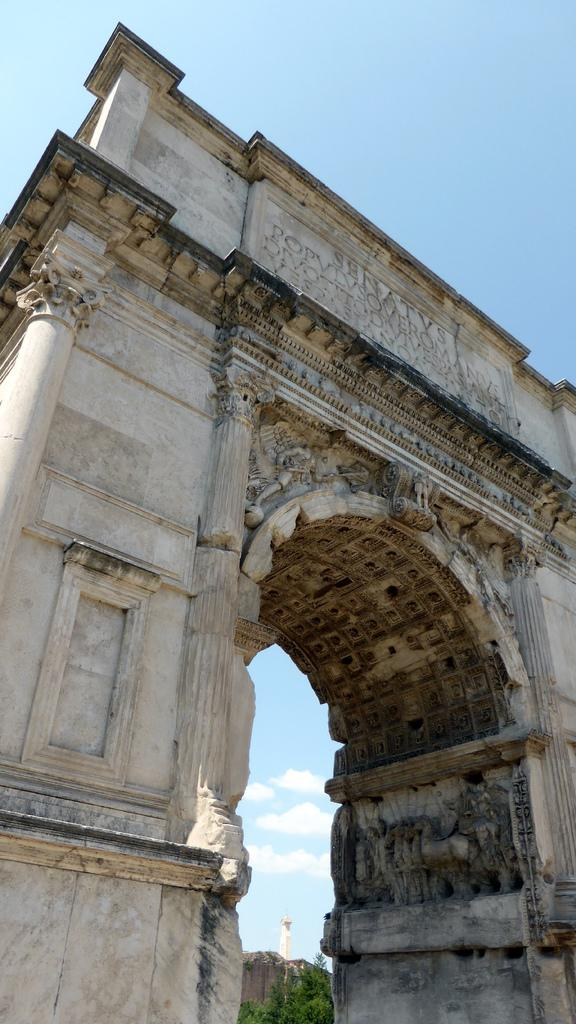Where was the image taken? The image was clicked outside. What is the main subject in the foreground of the image? There is a wall in the foreground of the image. What feature does the wall have? The wall has an arch. What is written on the wall? There is text on the wall. What can be seen in the background of the image? The sky is visible in the background of the image, along with other objects. What is the smell of the wall in the image? There is no information about the smell of the wall in the image, as it is a visual medium. 